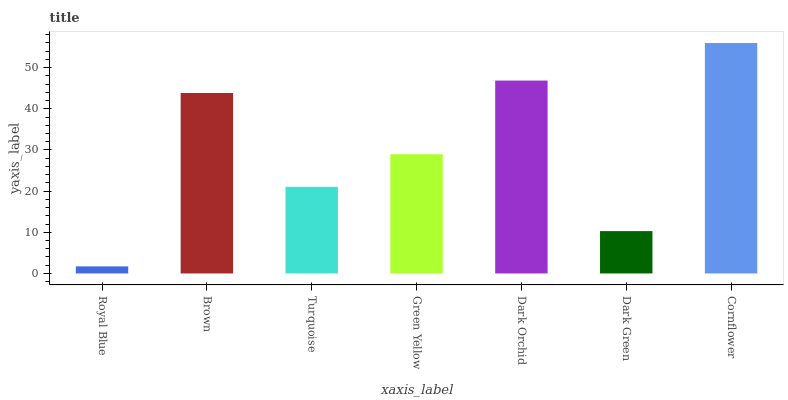Is Brown the minimum?
Answer yes or no. No. Is Brown the maximum?
Answer yes or no. No. Is Brown greater than Royal Blue?
Answer yes or no. Yes. Is Royal Blue less than Brown?
Answer yes or no. Yes. Is Royal Blue greater than Brown?
Answer yes or no. No. Is Brown less than Royal Blue?
Answer yes or no. No. Is Green Yellow the high median?
Answer yes or no. Yes. Is Green Yellow the low median?
Answer yes or no. Yes. Is Dark Green the high median?
Answer yes or no. No. Is Brown the low median?
Answer yes or no. No. 